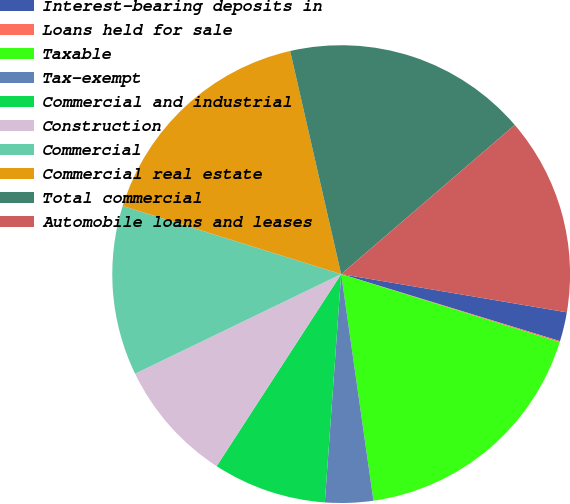Convert chart to OTSL. <chart><loc_0><loc_0><loc_500><loc_500><pie_chart><fcel>Interest-bearing deposits in<fcel>Loans held for sale<fcel>Taxable<fcel>Tax-exempt<fcel>Commercial and industrial<fcel>Construction<fcel>Commercial<fcel>Commercial real estate<fcel>Total commercial<fcel>Automobile loans and leases<nl><fcel>2.06%<fcel>0.08%<fcel>17.94%<fcel>3.39%<fcel>8.02%<fcel>8.68%<fcel>11.98%<fcel>16.61%<fcel>17.28%<fcel>13.97%<nl></chart> 